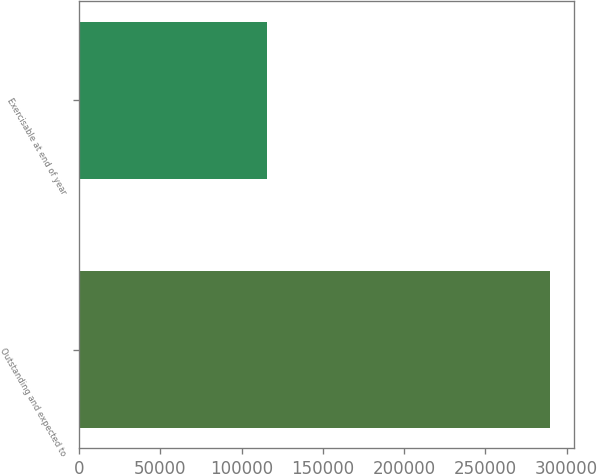<chart> <loc_0><loc_0><loc_500><loc_500><bar_chart><fcel>Outstanding and expected to<fcel>Exercisable at end of year<nl><fcel>289927<fcel>115290<nl></chart> 